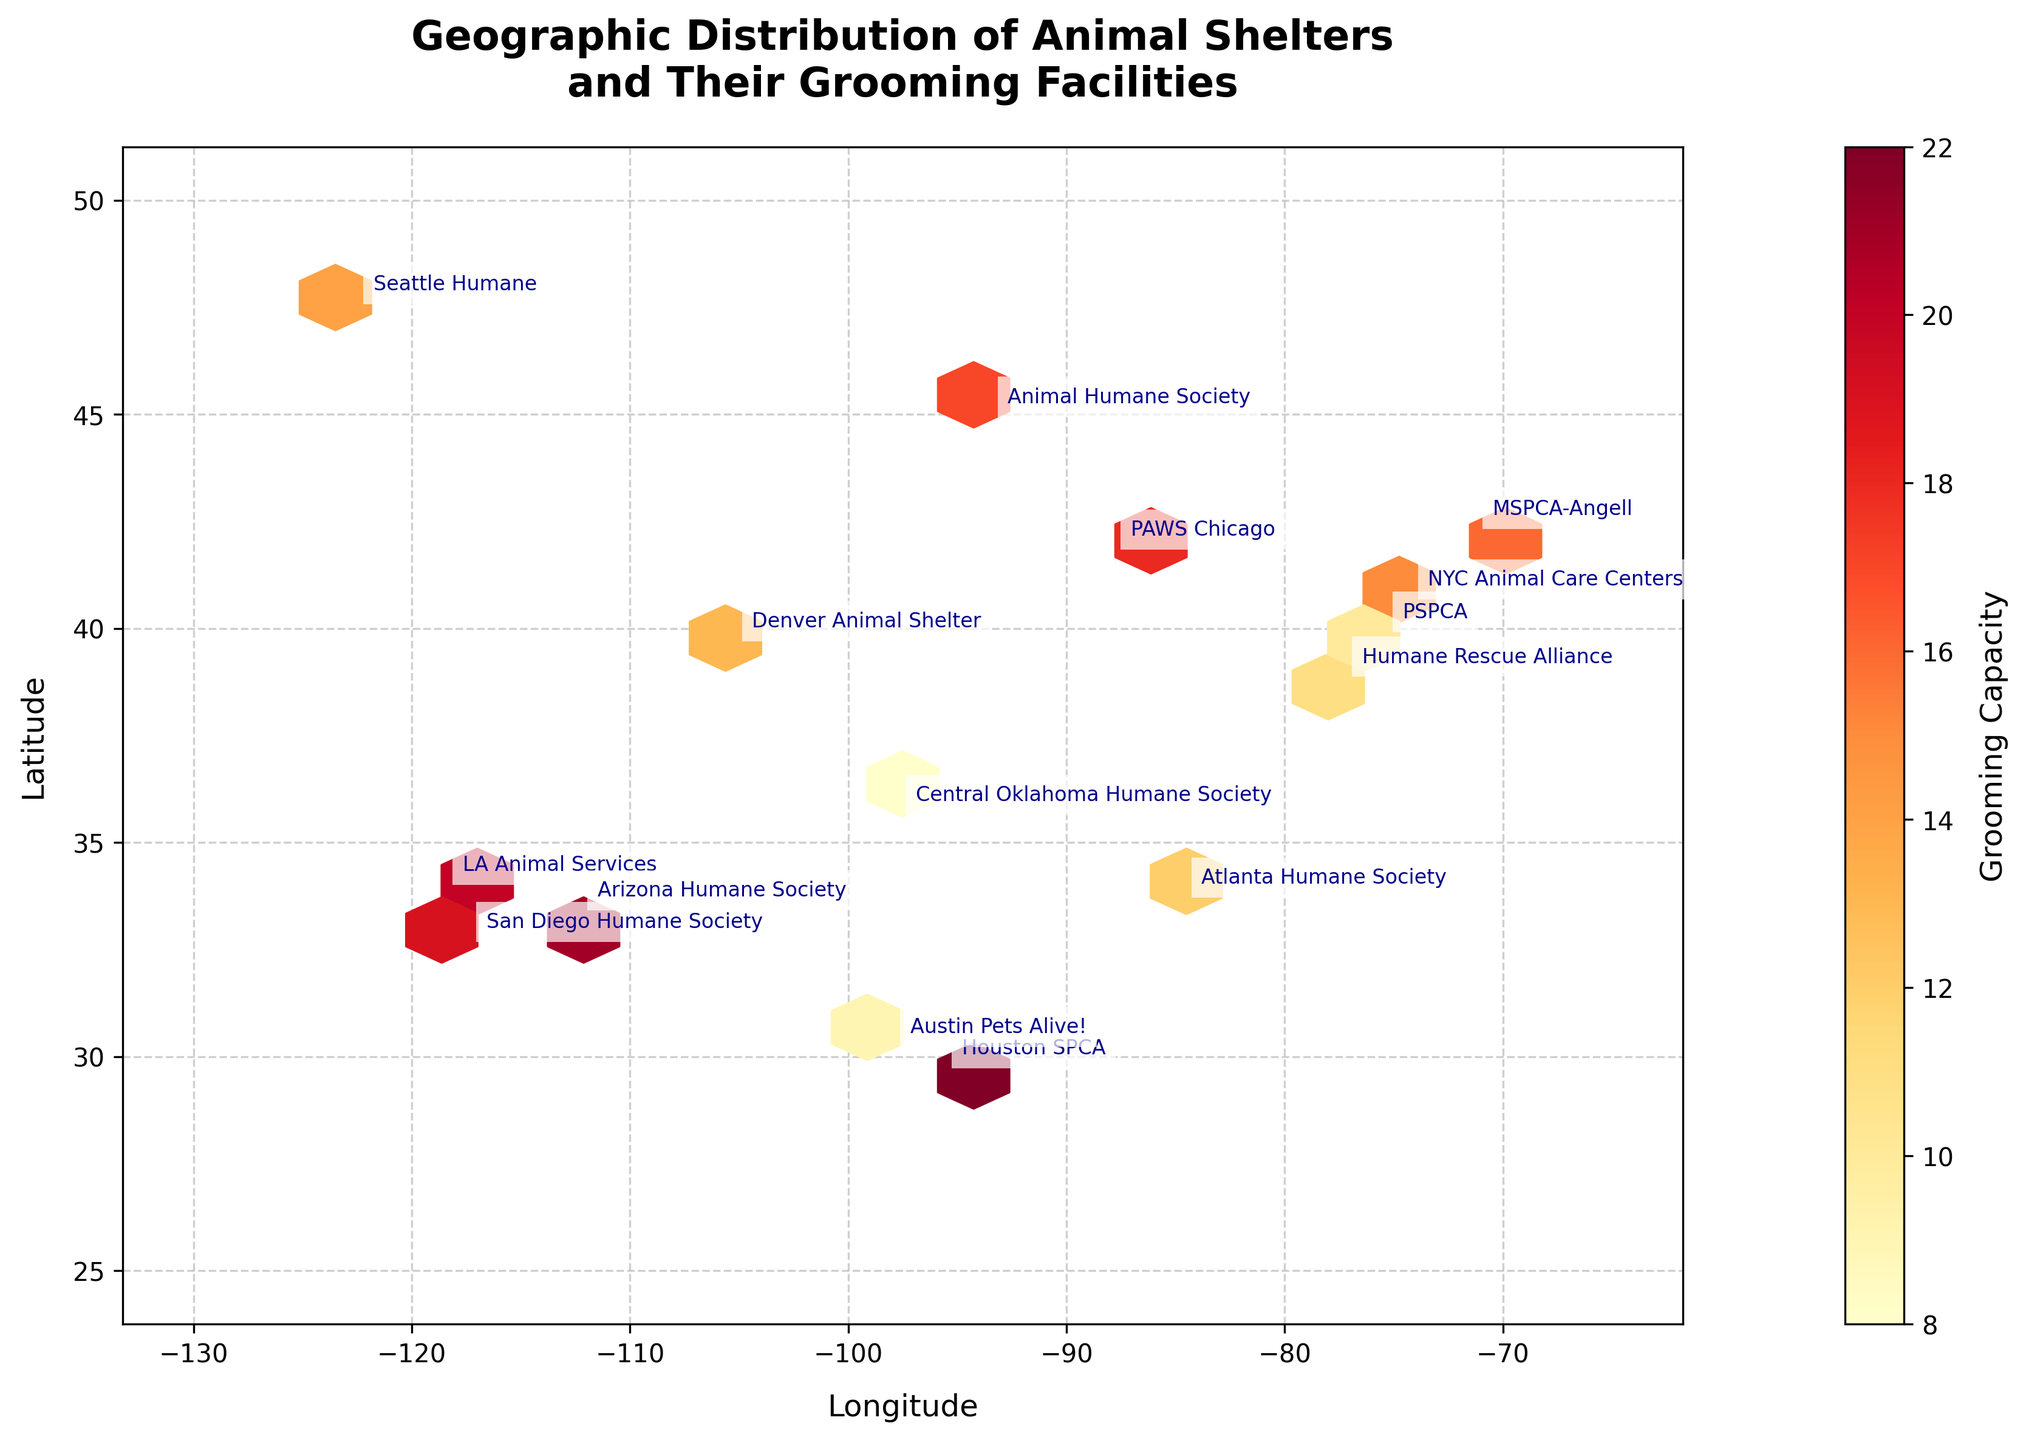What is the title of the hexbin plot? The title can be found at the top of the plot, typically in a larger font size and bold text. It summarizes the main information represented in the plot.
Answer: Geographic Distribution of Animal Shelters and Their Grooming Facilities What is shown on the x-axis and y-axis of the plot? The labels for each axis can usually be found along the respective axis, indicating what the plotted data represents.
Answer: Longitude on the x-axis and Latitude on the y-axis Which shelter has the highest grooming capacity, and what is that capacity? By observing the annotated names and corresponding colors on the hexbin grid, one can identify which shelter stands out with the highest grooming capacity.
Answer: Houston SPCA with a capacity of 22 How many shelters are located west of -100 longitude? By examining the plot and counting the shelters with longitude values greater than -100, one can determine the number of shelters in that region.
Answer: 7 Are there any animal shelters located at similar latitude levels (within 1 degree)? If so, name them. By comparing the latitude values of each shelter plotted on the y-axis, we can determine which shelters fall within a 1-degree range of each other.
Answer: San Diego Humane Society and LA Animal Services around latitude 33-34 Which region, western or eastern United States, generally has shelters with higher grooming capacities? Observing the overall color gradient of hexes across different geographical regions (west vs. east), which are separated roughly by the central longitude, one can determine the general trend in grooming capacity.
Answer: Western United States What color represents the highest grooming capacity on the plot, and what does the color represent? By referring to the color gradient in the plot, particularly the color bar legend, the color indicating the highest grooming capacities can be identified.
Answer: Dark red, representing the highest grooming capacities How does the shelter with the lowest grooming capacity compare to others in terms of geographic location? Observing the geographic position of the shelter with the lowest annotation label and comparing it to others can provide insights into its location.
Answer: Central Oklahoma Humane Society in the central U.S Which shelter is geographically closest to San Diego Humane Society? By observing the plot and noting the nearest annotated name to the San Diego Humane Society location, one can determine the closest shelter.
Answer: LA Animal Services Are there any visible clusters of animal shelters with similar grooming capacities? Observing the concentration of similarly colored hexes (primarily within the color bar range) can identify clusters of shelters with similar grooming capacities.
Answer: Yes, several clusters are visible 